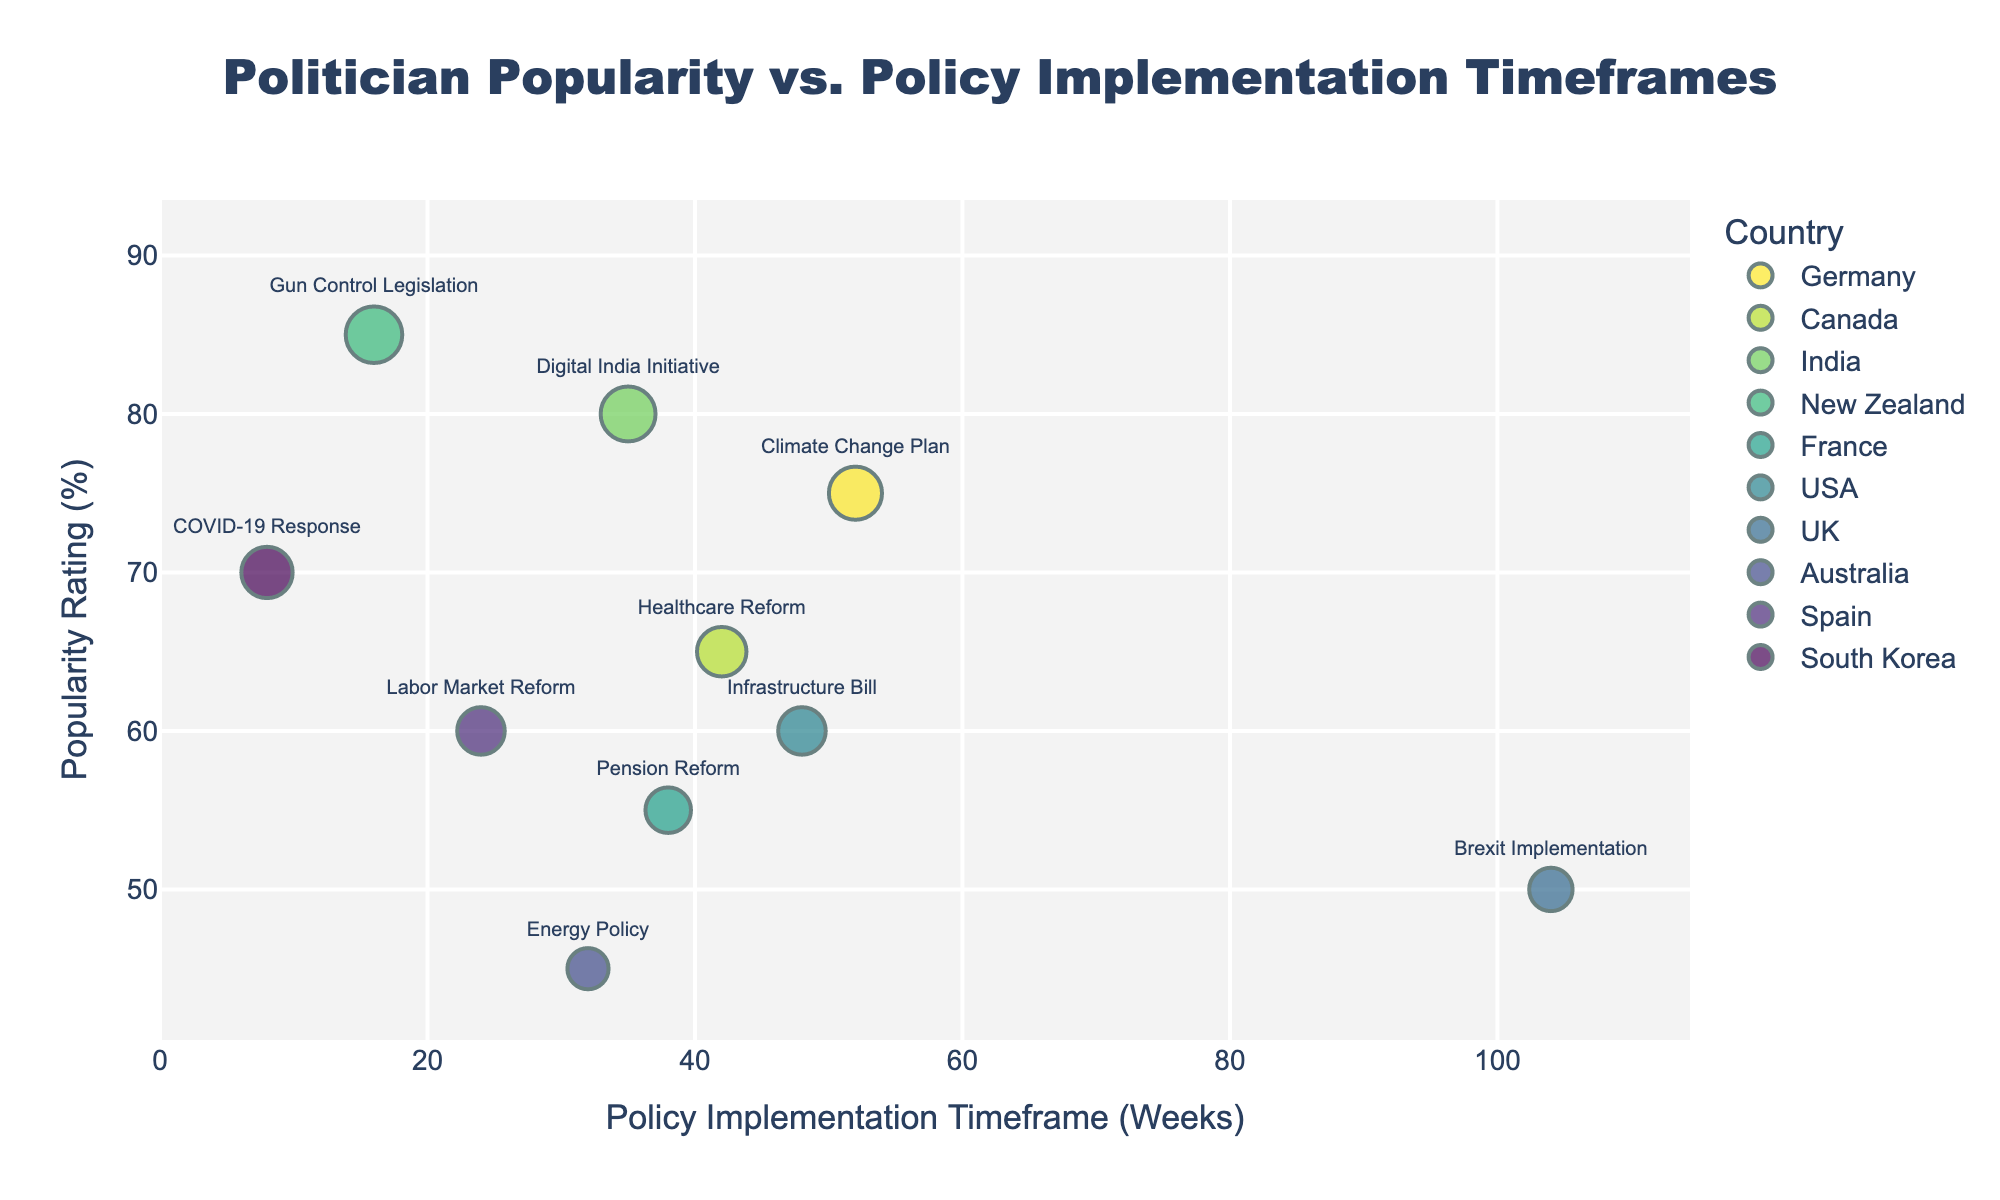how many data points are plotted in the figure? By counting all the distinct markers representing different politicians, we can see there are 10 data points.
Answer: 10 Which politician has the highest popularity rating? By looking at the y-axis and identifying the highest point, Jacinda Ardern from New Zealand has a popularity rating of 85%.
Answer: Jacinda Ardern How long did it take for Narendra Modi to implement his policy? By locating Narendra Modi's data point and referring to the x-axis, it took 35 weeks for the Digital India Initiative.
Answer: 35 weeks Which policy took the longest time to implement? By identifying the data point farthest to the right on the x-axis, Brexit Implementation by Boris Johnson took 104 weeks.
Answer: Brexit Implementation What is the popularity rating difference between Justin Trudeau and Joe Biden? Justin Trudeau's popularity rating is 65% and Joe Biden's is 60%. The difference is 65 - 60 = 5%.
Answer: 5% How many policies took more than 40 weeks to implement? By examining the x-axis and counting the data points beyond the 40-week mark: Angela Merkel, Joe Biden, Emmanuel Macron, and Boris Johnson, there are 4 policies.
Answer: 4 Does the country with the highest popularity rating implement policies faster or slower than the country with the lowest popularity rating? New Zealand, represented by Jacinda Ardern with the highest rating (85%), implemented its policy in 16 weeks. Australia, represented by Scott Morrison with the lowest rating (45%), implemented its policy in 32 weeks. Observing the implementation time, New Zealand was faster.
Answer: Faster Which two countries have politicians that introduced their policies within the shortest and the longest timeframes? By looking at the extremes, Moon Jae-in from South Korea had the shortest timeframe (8 weeks) and Boris Johnson from the UK had the longest timeframe (104 weeks).
Answer: South Korea and UK Is there a visible trend between the popularity rating and the policy implementation timeframe across the politicians? The data points show no clear upward or downward trend that indicates a strong relationship between the popularity rating and the policy implementation timeframe.
Answer: No clear trend 